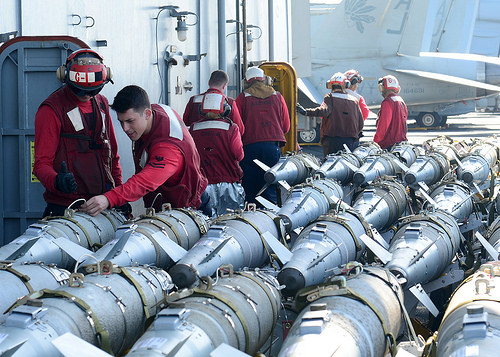<image>
Is the vest on the man? No. The vest is not positioned on the man. They may be near each other, but the vest is not supported by or resting on top of the man. 